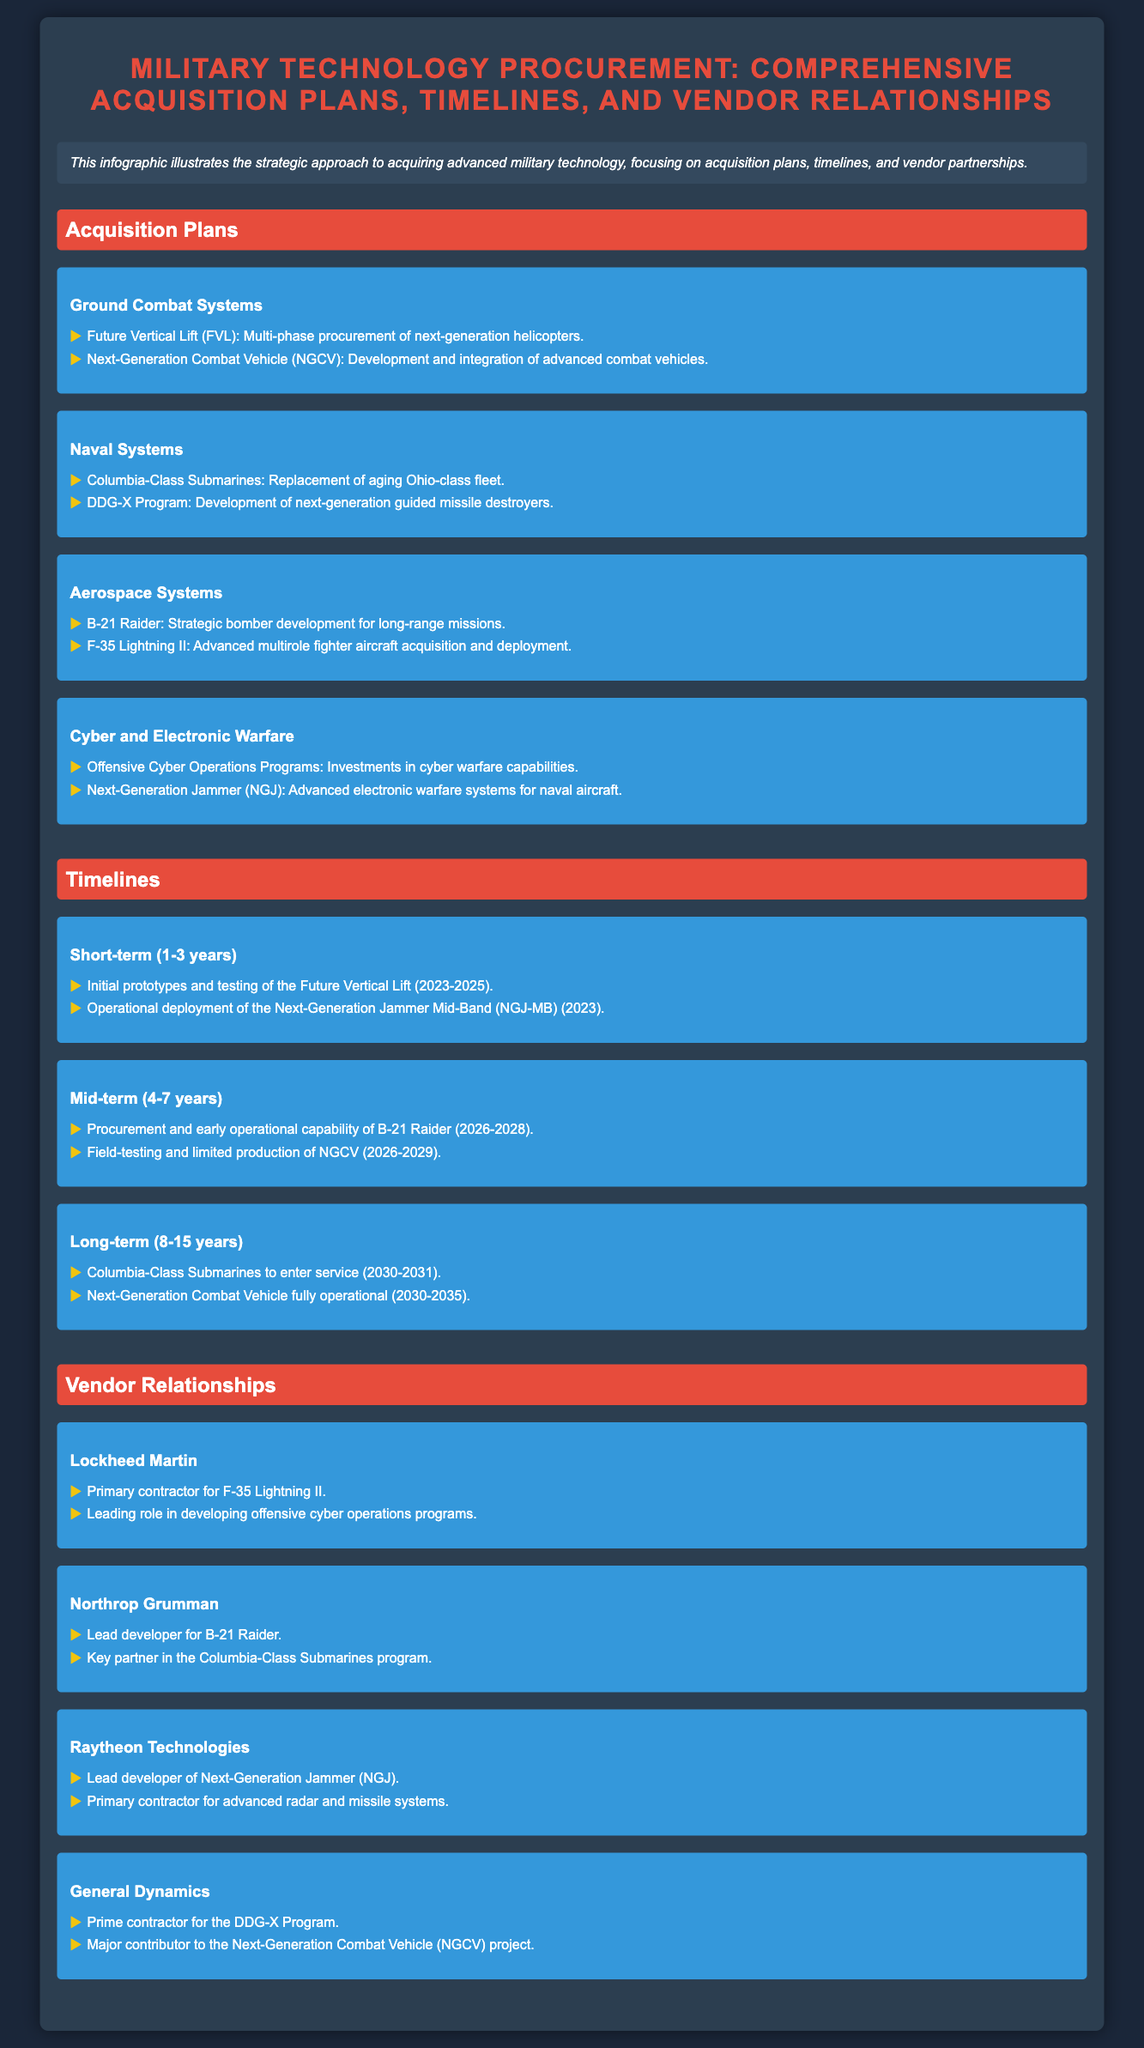what advanced fighter aircraft is mentioned? The advanced fighter aircraft mentioned in the document is the F-35 Lightning II.
Answer: F-35 Lightning II what is the procurement timeline for Columbia-Class Submarines? The procurement timeline for Columbia-Class Submarines is 2030-2031.
Answer: 2030-2031 who is the primary contractor for the B-21 Raider? The primary contractor for the B-21 Raider is Northrop Grumman.
Answer: Northrop Grumman which program is aimed at developing next-generation helicopters? The program aimed at developing next-generation helicopters is Future Vertical Lift (FVL).
Answer: Future Vertical Lift what category does Offensive Cyber Operations Programs fall under? Offensive Cyber Operations Programs fall under the Cyber and Electronic Warfare category.
Answer: Cyber and Electronic Warfare how many years is the mid-term timeline defined as? The mid-term timeline is defined as 4-7 years.
Answer: 4-7 years which company leads the development of Next-Generation Jammer? The company that leads the development of Next-Generation Jammer is Raytheon Technologies.
Answer: Raytheon Technologies what is the status of the Next-Generation Combat Vehicle (NGCV) by 2035? The status of the Next-Generation Combat Vehicle (NGCV) by 2035 is that it will be fully operational.
Answer: fully operational 